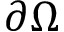<formula> <loc_0><loc_0><loc_500><loc_500>\partial \Omega</formula> 